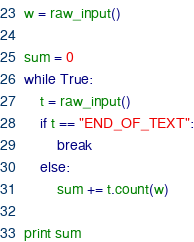<code> <loc_0><loc_0><loc_500><loc_500><_Python_>w = raw_input()

sum = 0
while True:
    t = raw_input()
    if t == "END_OF_TEXT":
        break
    else:
        sum += t.count(w)

print sum</code> 